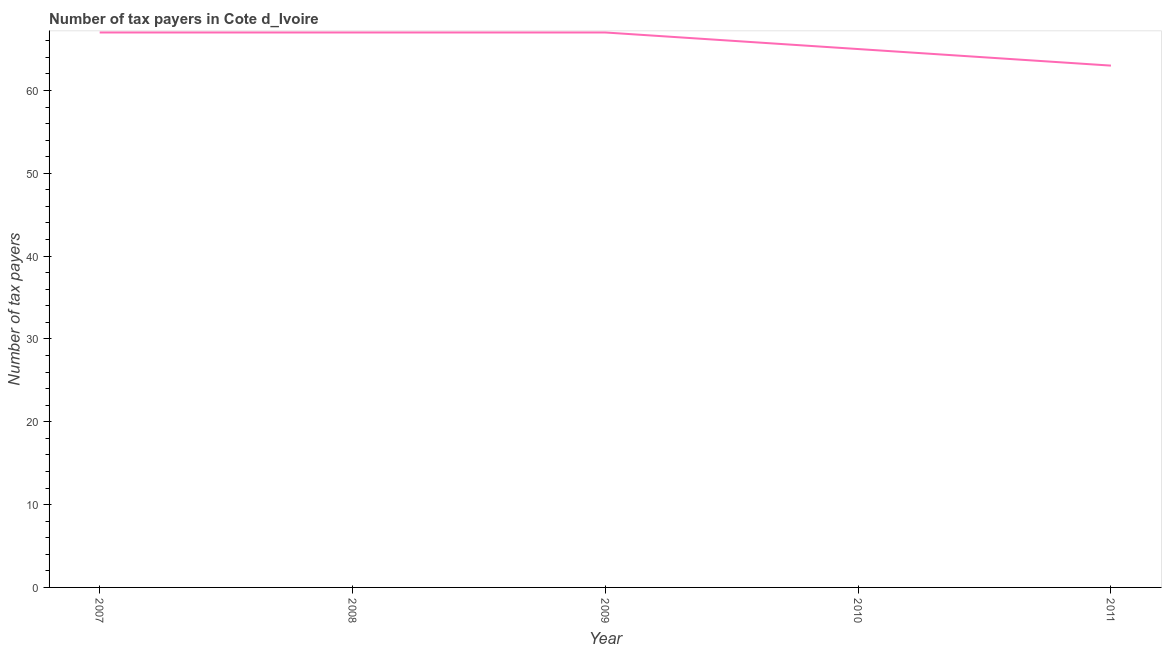What is the number of tax payers in 2011?
Provide a succinct answer. 63. Across all years, what is the maximum number of tax payers?
Your response must be concise. 67. Across all years, what is the minimum number of tax payers?
Your answer should be very brief. 63. In which year was the number of tax payers maximum?
Offer a terse response. 2007. In which year was the number of tax payers minimum?
Give a very brief answer. 2011. What is the sum of the number of tax payers?
Give a very brief answer. 329. What is the difference between the number of tax payers in 2007 and 2008?
Ensure brevity in your answer.  0. What is the average number of tax payers per year?
Make the answer very short. 65.8. What is the median number of tax payers?
Offer a terse response. 67. In how many years, is the number of tax payers greater than 56 ?
Give a very brief answer. 5. What is the ratio of the number of tax payers in 2008 to that in 2010?
Keep it short and to the point. 1.03. What is the difference between the highest and the second highest number of tax payers?
Offer a very short reply. 0. What is the difference between the highest and the lowest number of tax payers?
Your answer should be compact. 4. In how many years, is the number of tax payers greater than the average number of tax payers taken over all years?
Offer a very short reply. 3. What is the difference between two consecutive major ticks on the Y-axis?
Your answer should be compact. 10. Are the values on the major ticks of Y-axis written in scientific E-notation?
Offer a terse response. No. What is the title of the graph?
Your answer should be compact. Number of tax payers in Cote d_Ivoire. What is the label or title of the X-axis?
Keep it short and to the point. Year. What is the label or title of the Y-axis?
Offer a terse response. Number of tax payers. What is the Number of tax payers in 2007?
Your answer should be very brief. 67. What is the Number of tax payers of 2008?
Keep it short and to the point. 67. What is the Number of tax payers of 2009?
Your answer should be compact. 67. What is the Number of tax payers of 2011?
Keep it short and to the point. 63. What is the difference between the Number of tax payers in 2007 and 2009?
Give a very brief answer. 0. What is the difference between the Number of tax payers in 2007 and 2010?
Ensure brevity in your answer.  2. What is the difference between the Number of tax payers in 2007 and 2011?
Your answer should be very brief. 4. What is the difference between the Number of tax payers in 2008 and 2010?
Ensure brevity in your answer.  2. What is the difference between the Number of tax payers in 2009 and 2010?
Your answer should be compact. 2. What is the difference between the Number of tax payers in 2010 and 2011?
Offer a terse response. 2. What is the ratio of the Number of tax payers in 2007 to that in 2010?
Your answer should be compact. 1.03. What is the ratio of the Number of tax payers in 2007 to that in 2011?
Your response must be concise. 1.06. What is the ratio of the Number of tax payers in 2008 to that in 2009?
Your response must be concise. 1. What is the ratio of the Number of tax payers in 2008 to that in 2010?
Your answer should be very brief. 1.03. What is the ratio of the Number of tax payers in 2008 to that in 2011?
Your answer should be very brief. 1.06. What is the ratio of the Number of tax payers in 2009 to that in 2010?
Your answer should be compact. 1.03. What is the ratio of the Number of tax payers in 2009 to that in 2011?
Your answer should be very brief. 1.06. What is the ratio of the Number of tax payers in 2010 to that in 2011?
Make the answer very short. 1.03. 